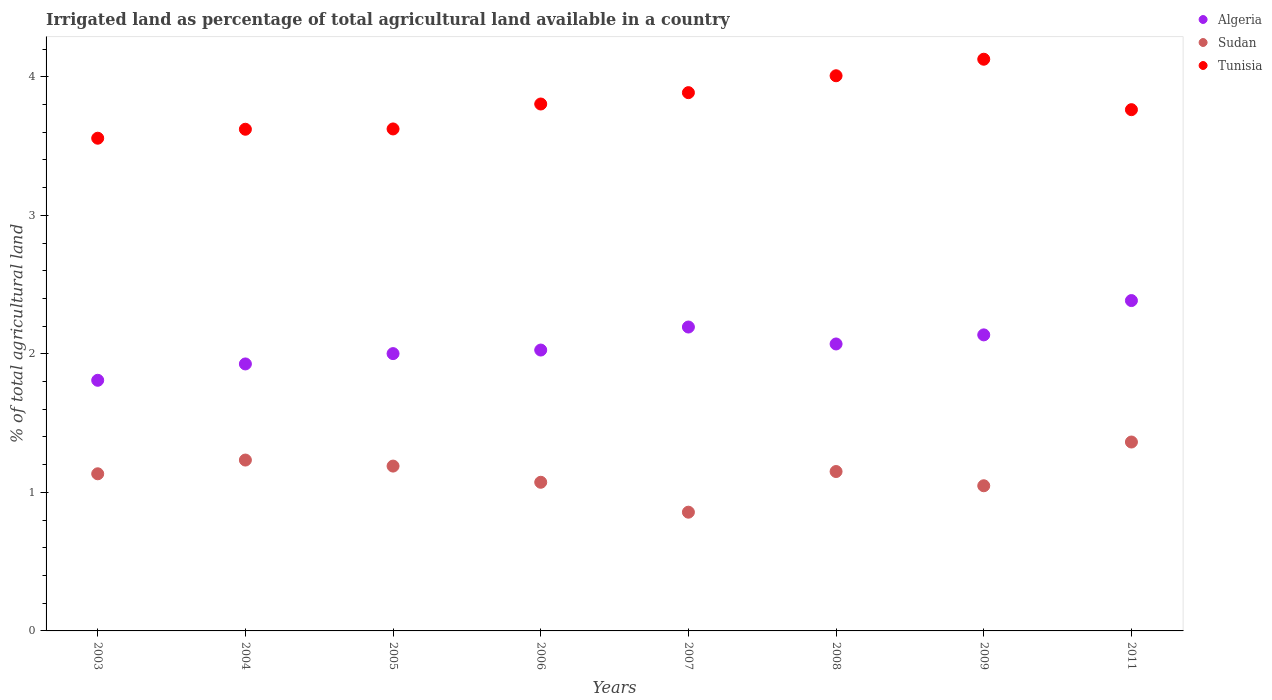How many different coloured dotlines are there?
Keep it short and to the point. 3. Is the number of dotlines equal to the number of legend labels?
Make the answer very short. Yes. What is the percentage of irrigated land in Algeria in 2004?
Provide a short and direct response. 1.93. Across all years, what is the maximum percentage of irrigated land in Algeria?
Your answer should be compact. 2.38. Across all years, what is the minimum percentage of irrigated land in Sudan?
Offer a terse response. 0.86. What is the total percentage of irrigated land in Sudan in the graph?
Provide a succinct answer. 9.05. What is the difference between the percentage of irrigated land in Tunisia in 2004 and that in 2006?
Your answer should be very brief. -0.18. What is the difference between the percentage of irrigated land in Tunisia in 2003 and the percentage of irrigated land in Sudan in 2009?
Provide a short and direct response. 2.51. What is the average percentage of irrigated land in Algeria per year?
Your answer should be very brief. 2.07. In the year 2006, what is the difference between the percentage of irrigated land in Algeria and percentage of irrigated land in Sudan?
Your answer should be very brief. 0.95. What is the ratio of the percentage of irrigated land in Sudan in 2004 to that in 2011?
Ensure brevity in your answer.  0.9. Is the percentage of irrigated land in Tunisia in 2009 less than that in 2011?
Offer a very short reply. No. What is the difference between the highest and the second highest percentage of irrigated land in Tunisia?
Provide a succinct answer. 0.12. What is the difference between the highest and the lowest percentage of irrigated land in Algeria?
Provide a succinct answer. 0.58. In how many years, is the percentage of irrigated land in Algeria greater than the average percentage of irrigated land in Algeria taken over all years?
Give a very brief answer. 4. Is the sum of the percentage of irrigated land in Tunisia in 2004 and 2007 greater than the maximum percentage of irrigated land in Sudan across all years?
Your response must be concise. Yes. Is it the case that in every year, the sum of the percentage of irrigated land in Algeria and percentage of irrigated land in Tunisia  is greater than the percentage of irrigated land in Sudan?
Your answer should be very brief. Yes. Does the percentage of irrigated land in Algeria monotonically increase over the years?
Your response must be concise. No. How many dotlines are there?
Provide a short and direct response. 3. How many years are there in the graph?
Offer a terse response. 8. What is the difference between two consecutive major ticks on the Y-axis?
Make the answer very short. 1. Are the values on the major ticks of Y-axis written in scientific E-notation?
Provide a succinct answer. No. Does the graph contain any zero values?
Your answer should be compact. No. Where does the legend appear in the graph?
Ensure brevity in your answer.  Top right. How are the legend labels stacked?
Your answer should be very brief. Vertical. What is the title of the graph?
Offer a very short reply. Irrigated land as percentage of total agricultural land available in a country. What is the label or title of the X-axis?
Provide a succinct answer. Years. What is the label or title of the Y-axis?
Ensure brevity in your answer.  % of total agricultural land. What is the % of total agricultural land of Algeria in 2003?
Provide a short and direct response. 1.81. What is the % of total agricultural land in Sudan in 2003?
Ensure brevity in your answer.  1.13. What is the % of total agricultural land in Tunisia in 2003?
Your answer should be very brief. 3.56. What is the % of total agricultural land in Algeria in 2004?
Ensure brevity in your answer.  1.93. What is the % of total agricultural land of Sudan in 2004?
Offer a very short reply. 1.23. What is the % of total agricultural land of Tunisia in 2004?
Keep it short and to the point. 3.62. What is the % of total agricultural land in Algeria in 2005?
Offer a terse response. 2. What is the % of total agricultural land in Sudan in 2005?
Your response must be concise. 1.19. What is the % of total agricultural land of Tunisia in 2005?
Provide a succinct answer. 3.62. What is the % of total agricultural land of Algeria in 2006?
Your response must be concise. 2.03. What is the % of total agricultural land in Sudan in 2006?
Your answer should be compact. 1.07. What is the % of total agricultural land of Tunisia in 2006?
Your answer should be very brief. 3.8. What is the % of total agricultural land of Algeria in 2007?
Provide a succinct answer. 2.19. What is the % of total agricultural land of Sudan in 2007?
Keep it short and to the point. 0.86. What is the % of total agricultural land in Tunisia in 2007?
Ensure brevity in your answer.  3.89. What is the % of total agricultural land in Algeria in 2008?
Make the answer very short. 2.07. What is the % of total agricultural land in Sudan in 2008?
Offer a terse response. 1.15. What is the % of total agricultural land in Tunisia in 2008?
Give a very brief answer. 4.01. What is the % of total agricultural land of Algeria in 2009?
Ensure brevity in your answer.  2.14. What is the % of total agricultural land of Sudan in 2009?
Provide a short and direct response. 1.05. What is the % of total agricultural land of Tunisia in 2009?
Ensure brevity in your answer.  4.13. What is the % of total agricultural land in Algeria in 2011?
Your response must be concise. 2.38. What is the % of total agricultural land of Sudan in 2011?
Give a very brief answer. 1.36. What is the % of total agricultural land of Tunisia in 2011?
Ensure brevity in your answer.  3.76. Across all years, what is the maximum % of total agricultural land in Algeria?
Keep it short and to the point. 2.38. Across all years, what is the maximum % of total agricultural land of Sudan?
Your answer should be very brief. 1.36. Across all years, what is the maximum % of total agricultural land of Tunisia?
Give a very brief answer. 4.13. Across all years, what is the minimum % of total agricultural land of Algeria?
Provide a succinct answer. 1.81. Across all years, what is the minimum % of total agricultural land in Sudan?
Provide a succinct answer. 0.86. Across all years, what is the minimum % of total agricultural land in Tunisia?
Your response must be concise. 3.56. What is the total % of total agricultural land of Algeria in the graph?
Provide a succinct answer. 16.55. What is the total % of total agricultural land in Sudan in the graph?
Your response must be concise. 9.05. What is the total % of total agricultural land in Tunisia in the graph?
Your answer should be very brief. 30.39. What is the difference between the % of total agricultural land of Algeria in 2003 and that in 2004?
Offer a terse response. -0.12. What is the difference between the % of total agricultural land of Sudan in 2003 and that in 2004?
Your answer should be compact. -0.1. What is the difference between the % of total agricultural land of Tunisia in 2003 and that in 2004?
Ensure brevity in your answer.  -0.06. What is the difference between the % of total agricultural land in Algeria in 2003 and that in 2005?
Your answer should be very brief. -0.19. What is the difference between the % of total agricultural land in Sudan in 2003 and that in 2005?
Provide a short and direct response. -0.06. What is the difference between the % of total agricultural land in Tunisia in 2003 and that in 2005?
Offer a very short reply. -0.07. What is the difference between the % of total agricultural land of Algeria in 2003 and that in 2006?
Ensure brevity in your answer.  -0.22. What is the difference between the % of total agricultural land of Sudan in 2003 and that in 2006?
Provide a succinct answer. 0.06. What is the difference between the % of total agricultural land of Tunisia in 2003 and that in 2006?
Your answer should be compact. -0.25. What is the difference between the % of total agricultural land in Algeria in 2003 and that in 2007?
Give a very brief answer. -0.38. What is the difference between the % of total agricultural land in Sudan in 2003 and that in 2007?
Make the answer very short. 0.28. What is the difference between the % of total agricultural land in Tunisia in 2003 and that in 2007?
Ensure brevity in your answer.  -0.33. What is the difference between the % of total agricultural land of Algeria in 2003 and that in 2008?
Make the answer very short. -0.26. What is the difference between the % of total agricultural land in Sudan in 2003 and that in 2008?
Your answer should be very brief. -0.02. What is the difference between the % of total agricultural land in Tunisia in 2003 and that in 2008?
Keep it short and to the point. -0.45. What is the difference between the % of total agricultural land in Algeria in 2003 and that in 2009?
Keep it short and to the point. -0.33. What is the difference between the % of total agricultural land of Sudan in 2003 and that in 2009?
Ensure brevity in your answer.  0.09. What is the difference between the % of total agricultural land of Tunisia in 2003 and that in 2009?
Offer a terse response. -0.57. What is the difference between the % of total agricultural land in Algeria in 2003 and that in 2011?
Offer a terse response. -0.58. What is the difference between the % of total agricultural land in Sudan in 2003 and that in 2011?
Make the answer very short. -0.23. What is the difference between the % of total agricultural land of Tunisia in 2003 and that in 2011?
Ensure brevity in your answer.  -0.21. What is the difference between the % of total agricultural land of Algeria in 2004 and that in 2005?
Give a very brief answer. -0.07. What is the difference between the % of total agricultural land of Sudan in 2004 and that in 2005?
Give a very brief answer. 0.04. What is the difference between the % of total agricultural land of Tunisia in 2004 and that in 2005?
Keep it short and to the point. -0. What is the difference between the % of total agricultural land in Algeria in 2004 and that in 2006?
Keep it short and to the point. -0.1. What is the difference between the % of total agricultural land in Sudan in 2004 and that in 2006?
Provide a succinct answer. 0.16. What is the difference between the % of total agricultural land in Tunisia in 2004 and that in 2006?
Ensure brevity in your answer.  -0.18. What is the difference between the % of total agricultural land of Algeria in 2004 and that in 2007?
Make the answer very short. -0.27. What is the difference between the % of total agricultural land of Sudan in 2004 and that in 2007?
Make the answer very short. 0.38. What is the difference between the % of total agricultural land in Tunisia in 2004 and that in 2007?
Make the answer very short. -0.26. What is the difference between the % of total agricultural land of Algeria in 2004 and that in 2008?
Make the answer very short. -0.14. What is the difference between the % of total agricultural land in Sudan in 2004 and that in 2008?
Make the answer very short. 0.08. What is the difference between the % of total agricultural land in Tunisia in 2004 and that in 2008?
Provide a succinct answer. -0.39. What is the difference between the % of total agricultural land of Algeria in 2004 and that in 2009?
Provide a short and direct response. -0.21. What is the difference between the % of total agricultural land of Sudan in 2004 and that in 2009?
Provide a succinct answer. 0.19. What is the difference between the % of total agricultural land in Tunisia in 2004 and that in 2009?
Your answer should be compact. -0.51. What is the difference between the % of total agricultural land of Algeria in 2004 and that in 2011?
Your response must be concise. -0.46. What is the difference between the % of total agricultural land of Sudan in 2004 and that in 2011?
Make the answer very short. -0.13. What is the difference between the % of total agricultural land in Tunisia in 2004 and that in 2011?
Your answer should be compact. -0.14. What is the difference between the % of total agricultural land of Algeria in 2005 and that in 2006?
Your response must be concise. -0.03. What is the difference between the % of total agricultural land in Sudan in 2005 and that in 2006?
Provide a short and direct response. 0.12. What is the difference between the % of total agricultural land of Tunisia in 2005 and that in 2006?
Offer a terse response. -0.18. What is the difference between the % of total agricultural land of Algeria in 2005 and that in 2007?
Provide a succinct answer. -0.19. What is the difference between the % of total agricultural land of Sudan in 2005 and that in 2007?
Provide a short and direct response. 0.33. What is the difference between the % of total agricultural land of Tunisia in 2005 and that in 2007?
Give a very brief answer. -0.26. What is the difference between the % of total agricultural land in Algeria in 2005 and that in 2008?
Keep it short and to the point. -0.07. What is the difference between the % of total agricultural land of Sudan in 2005 and that in 2008?
Provide a succinct answer. 0.04. What is the difference between the % of total agricultural land in Tunisia in 2005 and that in 2008?
Offer a very short reply. -0.38. What is the difference between the % of total agricultural land of Algeria in 2005 and that in 2009?
Offer a very short reply. -0.14. What is the difference between the % of total agricultural land in Sudan in 2005 and that in 2009?
Offer a very short reply. 0.14. What is the difference between the % of total agricultural land of Tunisia in 2005 and that in 2009?
Make the answer very short. -0.5. What is the difference between the % of total agricultural land in Algeria in 2005 and that in 2011?
Offer a terse response. -0.38. What is the difference between the % of total agricultural land in Sudan in 2005 and that in 2011?
Offer a very short reply. -0.17. What is the difference between the % of total agricultural land of Tunisia in 2005 and that in 2011?
Offer a terse response. -0.14. What is the difference between the % of total agricultural land in Algeria in 2006 and that in 2007?
Make the answer very short. -0.17. What is the difference between the % of total agricultural land in Sudan in 2006 and that in 2007?
Offer a terse response. 0.22. What is the difference between the % of total agricultural land in Tunisia in 2006 and that in 2007?
Provide a succinct answer. -0.08. What is the difference between the % of total agricultural land in Algeria in 2006 and that in 2008?
Provide a succinct answer. -0.04. What is the difference between the % of total agricultural land of Sudan in 2006 and that in 2008?
Offer a very short reply. -0.08. What is the difference between the % of total agricultural land in Tunisia in 2006 and that in 2008?
Provide a short and direct response. -0.2. What is the difference between the % of total agricultural land of Algeria in 2006 and that in 2009?
Provide a succinct answer. -0.11. What is the difference between the % of total agricultural land in Sudan in 2006 and that in 2009?
Keep it short and to the point. 0.03. What is the difference between the % of total agricultural land of Tunisia in 2006 and that in 2009?
Ensure brevity in your answer.  -0.32. What is the difference between the % of total agricultural land in Algeria in 2006 and that in 2011?
Provide a succinct answer. -0.36. What is the difference between the % of total agricultural land of Sudan in 2006 and that in 2011?
Make the answer very short. -0.29. What is the difference between the % of total agricultural land of Tunisia in 2006 and that in 2011?
Keep it short and to the point. 0.04. What is the difference between the % of total agricultural land of Algeria in 2007 and that in 2008?
Your answer should be compact. 0.12. What is the difference between the % of total agricultural land of Sudan in 2007 and that in 2008?
Your answer should be very brief. -0.29. What is the difference between the % of total agricultural land of Tunisia in 2007 and that in 2008?
Make the answer very short. -0.12. What is the difference between the % of total agricultural land of Algeria in 2007 and that in 2009?
Your answer should be very brief. 0.06. What is the difference between the % of total agricultural land of Sudan in 2007 and that in 2009?
Provide a short and direct response. -0.19. What is the difference between the % of total agricultural land in Tunisia in 2007 and that in 2009?
Offer a terse response. -0.24. What is the difference between the % of total agricultural land of Algeria in 2007 and that in 2011?
Offer a very short reply. -0.19. What is the difference between the % of total agricultural land in Sudan in 2007 and that in 2011?
Give a very brief answer. -0.51. What is the difference between the % of total agricultural land in Tunisia in 2007 and that in 2011?
Your answer should be compact. 0.12. What is the difference between the % of total agricultural land of Algeria in 2008 and that in 2009?
Offer a very short reply. -0.07. What is the difference between the % of total agricultural land in Sudan in 2008 and that in 2009?
Your answer should be very brief. 0.1. What is the difference between the % of total agricultural land of Tunisia in 2008 and that in 2009?
Your answer should be compact. -0.12. What is the difference between the % of total agricultural land in Algeria in 2008 and that in 2011?
Your answer should be very brief. -0.31. What is the difference between the % of total agricultural land of Sudan in 2008 and that in 2011?
Provide a succinct answer. -0.21. What is the difference between the % of total agricultural land in Tunisia in 2008 and that in 2011?
Your answer should be very brief. 0.24. What is the difference between the % of total agricultural land of Algeria in 2009 and that in 2011?
Your answer should be compact. -0.25. What is the difference between the % of total agricultural land in Sudan in 2009 and that in 2011?
Keep it short and to the point. -0.32. What is the difference between the % of total agricultural land in Tunisia in 2009 and that in 2011?
Provide a short and direct response. 0.36. What is the difference between the % of total agricultural land in Algeria in 2003 and the % of total agricultural land in Sudan in 2004?
Ensure brevity in your answer.  0.58. What is the difference between the % of total agricultural land in Algeria in 2003 and the % of total agricultural land in Tunisia in 2004?
Give a very brief answer. -1.81. What is the difference between the % of total agricultural land of Sudan in 2003 and the % of total agricultural land of Tunisia in 2004?
Provide a succinct answer. -2.49. What is the difference between the % of total agricultural land of Algeria in 2003 and the % of total agricultural land of Sudan in 2005?
Your response must be concise. 0.62. What is the difference between the % of total agricultural land of Algeria in 2003 and the % of total agricultural land of Tunisia in 2005?
Your answer should be very brief. -1.81. What is the difference between the % of total agricultural land in Sudan in 2003 and the % of total agricultural land in Tunisia in 2005?
Offer a terse response. -2.49. What is the difference between the % of total agricultural land of Algeria in 2003 and the % of total agricultural land of Sudan in 2006?
Your answer should be compact. 0.74. What is the difference between the % of total agricultural land in Algeria in 2003 and the % of total agricultural land in Tunisia in 2006?
Your response must be concise. -1.99. What is the difference between the % of total agricultural land of Sudan in 2003 and the % of total agricultural land of Tunisia in 2006?
Offer a terse response. -2.67. What is the difference between the % of total agricultural land of Algeria in 2003 and the % of total agricultural land of Sudan in 2007?
Provide a short and direct response. 0.95. What is the difference between the % of total agricultural land in Algeria in 2003 and the % of total agricultural land in Tunisia in 2007?
Make the answer very short. -2.08. What is the difference between the % of total agricultural land of Sudan in 2003 and the % of total agricultural land of Tunisia in 2007?
Offer a very short reply. -2.75. What is the difference between the % of total agricultural land in Algeria in 2003 and the % of total agricultural land in Sudan in 2008?
Make the answer very short. 0.66. What is the difference between the % of total agricultural land in Algeria in 2003 and the % of total agricultural land in Tunisia in 2008?
Offer a very short reply. -2.2. What is the difference between the % of total agricultural land of Sudan in 2003 and the % of total agricultural land of Tunisia in 2008?
Your response must be concise. -2.87. What is the difference between the % of total agricultural land in Algeria in 2003 and the % of total agricultural land in Sudan in 2009?
Offer a very short reply. 0.76. What is the difference between the % of total agricultural land of Algeria in 2003 and the % of total agricultural land of Tunisia in 2009?
Make the answer very short. -2.32. What is the difference between the % of total agricultural land of Sudan in 2003 and the % of total agricultural land of Tunisia in 2009?
Ensure brevity in your answer.  -2.99. What is the difference between the % of total agricultural land in Algeria in 2003 and the % of total agricultural land in Sudan in 2011?
Keep it short and to the point. 0.45. What is the difference between the % of total agricultural land in Algeria in 2003 and the % of total agricultural land in Tunisia in 2011?
Your answer should be very brief. -1.95. What is the difference between the % of total agricultural land in Sudan in 2003 and the % of total agricultural land in Tunisia in 2011?
Make the answer very short. -2.63. What is the difference between the % of total agricultural land in Algeria in 2004 and the % of total agricultural land in Sudan in 2005?
Offer a terse response. 0.74. What is the difference between the % of total agricultural land of Algeria in 2004 and the % of total agricultural land of Tunisia in 2005?
Keep it short and to the point. -1.7. What is the difference between the % of total agricultural land of Sudan in 2004 and the % of total agricultural land of Tunisia in 2005?
Provide a succinct answer. -2.39. What is the difference between the % of total agricultural land in Algeria in 2004 and the % of total agricultural land in Sudan in 2006?
Keep it short and to the point. 0.85. What is the difference between the % of total agricultural land in Algeria in 2004 and the % of total agricultural land in Tunisia in 2006?
Your answer should be very brief. -1.88. What is the difference between the % of total agricultural land of Sudan in 2004 and the % of total agricultural land of Tunisia in 2006?
Give a very brief answer. -2.57. What is the difference between the % of total agricultural land of Algeria in 2004 and the % of total agricultural land of Sudan in 2007?
Offer a very short reply. 1.07. What is the difference between the % of total agricultural land in Algeria in 2004 and the % of total agricultural land in Tunisia in 2007?
Ensure brevity in your answer.  -1.96. What is the difference between the % of total agricultural land of Sudan in 2004 and the % of total agricultural land of Tunisia in 2007?
Your answer should be compact. -2.65. What is the difference between the % of total agricultural land in Algeria in 2004 and the % of total agricultural land in Sudan in 2008?
Ensure brevity in your answer.  0.78. What is the difference between the % of total agricultural land of Algeria in 2004 and the % of total agricultural land of Tunisia in 2008?
Your response must be concise. -2.08. What is the difference between the % of total agricultural land of Sudan in 2004 and the % of total agricultural land of Tunisia in 2008?
Make the answer very short. -2.77. What is the difference between the % of total agricultural land of Algeria in 2004 and the % of total agricultural land of Sudan in 2009?
Give a very brief answer. 0.88. What is the difference between the % of total agricultural land in Algeria in 2004 and the % of total agricultural land in Tunisia in 2009?
Your response must be concise. -2.2. What is the difference between the % of total agricultural land of Sudan in 2004 and the % of total agricultural land of Tunisia in 2009?
Keep it short and to the point. -2.89. What is the difference between the % of total agricultural land in Algeria in 2004 and the % of total agricultural land in Sudan in 2011?
Give a very brief answer. 0.56. What is the difference between the % of total agricultural land in Algeria in 2004 and the % of total agricultural land in Tunisia in 2011?
Your answer should be very brief. -1.84. What is the difference between the % of total agricultural land of Sudan in 2004 and the % of total agricultural land of Tunisia in 2011?
Give a very brief answer. -2.53. What is the difference between the % of total agricultural land of Algeria in 2005 and the % of total agricultural land of Sudan in 2006?
Your response must be concise. 0.93. What is the difference between the % of total agricultural land of Algeria in 2005 and the % of total agricultural land of Tunisia in 2006?
Keep it short and to the point. -1.8. What is the difference between the % of total agricultural land of Sudan in 2005 and the % of total agricultural land of Tunisia in 2006?
Keep it short and to the point. -2.61. What is the difference between the % of total agricultural land of Algeria in 2005 and the % of total agricultural land of Sudan in 2007?
Keep it short and to the point. 1.14. What is the difference between the % of total agricultural land of Algeria in 2005 and the % of total agricultural land of Tunisia in 2007?
Provide a succinct answer. -1.88. What is the difference between the % of total agricultural land in Sudan in 2005 and the % of total agricultural land in Tunisia in 2007?
Provide a short and direct response. -2.7. What is the difference between the % of total agricultural land in Algeria in 2005 and the % of total agricultural land in Sudan in 2008?
Keep it short and to the point. 0.85. What is the difference between the % of total agricultural land in Algeria in 2005 and the % of total agricultural land in Tunisia in 2008?
Provide a succinct answer. -2.01. What is the difference between the % of total agricultural land in Sudan in 2005 and the % of total agricultural land in Tunisia in 2008?
Give a very brief answer. -2.82. What is the difference between the % of total agricultural land of Algeria in 2005 and the % of total agricultural land of Sudan in 2009?
Keep it short and to the point. 0.95. What is the difference between the % of total agricultural land of Algeria in 2005 and the % of total agricultural land of Tunisia in 2009?
Ensure brevity in your answer.  -2.13. What is the difference between the % of total agricultural land of Sudan in 2005 and the % of total agricultural land of Tunisia in 2009?
Your answer should be compact. -2.94. What is the difference between the % of total agricultural land of Algeria in 2005 and the % of total agricultural land of Sudan in 2011?
Your answer should be very brief. 0.64. What is the difference between the % of total agricultural land in Algeria in 2005 and the % of total agricultural land in Tunisia in 2011?
Ensure brevity in your answer.  -1.76. What is the difference between the % of total agricultural land of Sudan in 2005 and the % of total agricultural land of Tunisia in 2011?
Your response must be concise. -2.57. What is the difference between the % of total agricultural land in Algeria in 2006 and the % of total agricultural land in Sudan in 2007?
Offer a terse response. 1.17. What is the difference between the % of total agricultural land of Algeria in 2006 and the % of total agricultural land of Tunisia in 2007?
Provide a short and direct response. -1.86. What is the difference between the % of total agricultural land of Sudan in 2006 and the % of total agricultural land of Tunisia in 2007?
Give a very brief answer. -2.81. What is the difference between the % of total agricultural land in Algeria in 2006 and the % of total agricultural land in Sudan in 2008?
Ensure brevity in your answer.  0.88. What is the difference between the % of total agricultural land in Algeria in 2006 and the % of total agricultural land in Tunisia in 2008?
Your answer should be very brief. -1.98. What is the difference between the % of total agricultural land of Sudan in 2006 and the % of total agricultural land of Tunisia in 2008?
Your answer should be compact. -2.93. What is the difference between the % of total agricultural land of Algeria in 2006 and the % of total agricultural land of Sudan in 2009?
Make the answer very short. 0.98. What is the difference between the % of total agricultural land of Algeria in 2006 and the % of total agricultural land of Tunisia in 2009?
Offer a terse response. -2.1. What is the difference between the % of total agricultural land in Sudan in 2006 and the % of total agricultural land in Tunisia in 2009?
Give a very brief answer. -3.05. What is the difference between the % of total agricultural land of Algeria in 2006 and the % of total agricultural land of Sudan in 2011?
Offer a very short reply. 0.66. What is the difference between the % of total agricultural land in Algeria in 2006 and the % of total agricultural land in Tunisia in 2011?
Provide a succinct answer. -1.74. What is the difference between the % of total agricultural land of Sudan in 2006 and the % of total agricultural land of Tunisia in 2011?
Make the answer very short. -2.69. What is the difference between the % of total agricultural land in Algeria in 2007 and the % of total agricultural land in Sudan in 2008?
Give a very brief answer. 1.04. What is the difference between the % of total agricultural land in Algeria in 2007 and the % of total agricultural land in Tunisia in 2008?
Keep it short and to the point. -1.81. What is the difference between the % of total agricultural land in Sudan in 2007 and the % of total agricultural land in Tunisia in 2008?
Your response must be concise. -3.15. What is the difference between the % of total agricultural land in Algeria in 2007 and the % of total agricultural land in Sudan in 2009?
Ensure brevity in your answer.  1.15. What is the difference between the % of total agricultural land of Algeria in 2007 and the % of total agricultural land of Tunisia in 2009?
Your answer should be compact. -1.93. What is the difference between the % of total agricultural land of Sudan in 2007 and the % of total agricultural land of Tunisia in 2009?
Your answer should be compact. -3.27. What is the difference between the % of total agricultural land in Algeria in 2007 and the % of total agricultural land in Sudan in 2011?
Offer a terse response. 0.83. What is the difference between the % of total agricultural land of Algeria in 2007 and the % of total agricultural land of Tunisia in 2011?
Provide a succinct answer. -1.57. What is the difference between the % of total agricultural land of Sudan in 2007 and the % of total agricultural land of Tunisia in 2011?
Give a very brief answer. -2.91. What is the difference between the % of total agricultural land in Algeria in 2008 and the % of total agricultural land in Sudan in 2009?
Provide a succinct answer. 1.02. What is the difference between the % of total agricultural land in Algeria in 2008 and the % of total agricultural land in Tunisia in 2009?
Your answer should be compact. -2.06. What is the difference between the % of total agricultural land in Sudan in 2008 and the % of total agricultural land in Tunisia in 2009?
Your response must be concise. -2.98. What is the difference between the % of total agricultural land of Algeria in 2008 and the % of total agricultural land of Sudan in 2011?
Give a very brief answer. 0.71. What is the difference between the % of total agricultural land of Algeria in 2008 and the % of total agricultural land of Tunisia in 2011?
Give a very brief answer. -1.69. What is the difference between the % of total agricultural land in Sudan in 2008 and the % of total agricultural land in Tunisia in 2011?
Your response must be concise. -2.61. What is the difference between the % of total agricultural land in Algeria in 2009 and the % of total agricultural land in Sudan in 2011?
Provide a short and direct response. 0.77. What is the difference between the % of total agricultural land of Algeria in 2009 and the % of total agricultural land of Tunisia in 2011?
Your answer should be compact. -1.63. What is the difference between the % of total agricultural land in Sudan in 2009 and the % of total agricultural land in Tunisia in 2011?
Offer a terse response. -2.71. What is the average % of total agricultural land in Algeria per year?
Ensure brevity in your answer.  2.07. What is the average % of total agricultural land of Sudan per year?
Give a very brief answer. 1.13. What is the average % of total agricultural land in Tunisia per year?
Your response must be concise. 3.8. In the year 2003, what is the difference between the % of total agricultural land of Algeria and % of total agricultural land of Sudan?
Your answer should be very brief. 0.67. In the year 2003, what is the difference between the % of total agricultural land in Algeria and % of total agricultural land in Tunisia?
Make the answer very short. -1.75. In the year 2003, what is the difference between the % of total agricultural land in Sudan and % of total agricultural land in Tunisia?
Provide a succinct answer. -2.42. In the year 2004, what is the difference between the % of total agricultural land of Algeria and % of total agricultural land of Sudan?
Give a very brief answer. 0.69. In the year 2004, what is the difference between the % of total agricultural land of Algeria and % of total agricultural land of Tunisia?
Ensure brevity in your answer.  -1.69. In the year 2004, what is the difference between the % of total agricultural land of Sudan and % of total agricultural land of Tunisia?
Provide a succinct answer. -2.39. In the year 2005, what is the difference between the % of total agricultural land of Algeria and % of total agricultural land of Sudan?
Keep it short and to the point. 0.81. In the year 2005, what is the difference between the % of total agricultural land in Algeria and % of total agricultural land in Tunisia?
Your response must be concise. -1.62. In the year 2005, what is the difference between the % of total agricultural land in Sudan and % of total agricultural land in Tunisia?
Offer a terse response. -2.43. In the year 2006, what is the difference between the % of total agricultural land of Algeria and % of total agricultural land of Sudan?
Provide a short and direct response. 0.95. In the year 2006, what is the difference between the % of total agricultural land in Algeria and % of total agricultural land in Tunisia?
Give a very brief answer. -1.78. In the year 2006, what is the difference between the % of total agricultural land in Sudan and % of total agricultural land in Tunisia?
Provide a short and direct response. -2.73. In the year 2007, what is the difference between the % of total agricultural land in Algeria and % of total agricultural land in Sudan?
Provide a short and direct response. 1.34. In the year 2007, what is the difference between the % of total agricultural land of Algeria and % of total agricultural land of Tunisia?
Your answer should be very brief. -1.69. In the year 2007, what is the difference between the % of total agricultural land in Sudan and % of total agricultural land in Tunisia?
Offer a terse response. -3.03. In the year 2008, what is the difference between the % of total agricultural land in Algeria and % of total agricultural land in Sudan?
Keep it short and to the point. 0.92. In the year 2008, what is the difference between the % of total agricultural land in Algeria and % of total agricultural land in Tunisia?
Offer a very short reply. -1.94. In the year 2008, what is the difference between the % of total agricultural land in Sudan and % of total agricultural land in Tunisia?
Your answer should be very brief. -2.86. In the year 2009, what is the difference between the % of total agricultural land of Algeria and % of total agricultural land of Sudan?
Offer a very short reply. 1.09. In the year 2009, what is the difference between the % of total agricultural land of Algeria and % of total agricultural land of Tunisia?
Ensure brevity in your answer.  -1.99. In the year 2009, what is the difference between the % of total agricultural land of Sudan and % of total agricultural land of Tunisia?
Ensure brevity in your answer.  -3.08. In the year 2011, what is the difference between the % of total agricultural land of Algeria and % of total agricultural land of Sudan?
Provide a succinct answer. 1.02. In the year 2011, what is the difference between the % of total agricultural land of Algeria and % of total agricultural land of Tunisia?
Offer a very short reply. -1.38. In the year 2011, what is the difference between the % of total agricultural land of Sudan and % of total agricultural land of Tunisia?
Provide a short and direct response. -2.4. What is the ratio of the % of total agricultural land of Algeria in 2003 to that in 2004?
Keep it short and to the point. 0.94. What is the ratio of the % of total agricultural land in Sudan in 2003 to that in 2004?
Make the answer very short. 0.92. What is the ratio of the % of total agricultural land of Tunisia in 2003 to that in 2004?
Keep it short and to the point. 0.98. What is the ratio of the % of total agricultural land in Algeria in 2003 to that in 2005?
Ensure brevity in your answer.  0.9. What is the ratio of the % of total agricultural land in Sudan in 2003 to that in 2005?
Your answer should be compact. 0.95. What is the ratio of the % of total agricultural land in Tunisia in 2003 to that in 2005?
Ensure brevity in your answer.  0.98. What is the ratio of the % of total agricultural land in Algeria in 2003 to that in 2006?
Ensure brevity in your answer.  0.89. What is the ratio of the % of total agricultural land of Sudan in 2003 to that in 2006?
Provide a short and direct response. 1.06. What is the ratio of the % of total agricultural land of Tunisia in 2003 to that in 2006?
Offer a very short reply. 0.94. What is the ratio of the % of total agricultural land of Algeria in 2003 to that in 2007?
Your answer should be very brief. 0.82. What is the ratio of the % of total agricultural land in Sudan in 2003 to that in 2007?
Your answer should be compact. 1.32. What is the ratio of the % of total agricultural land of Tunisia in 2003 to that in 2007?
Your answer should be compact. 0.92. What is the ratio of the % of total agricultural land of Algeria in 2003 to that in 2008?
Offer a very short reply. 0.87. What is the ratio of the % of total agricultural land of Sudan in 2003 to that in 2008?
Your answer should be very brief. 0.99. What is the ratio of the % of total agricultural land of Tunisia in 2003 to that in 2008?
Offer a very short reply. 0.89. What is the ratio of the % of total agricultural land in Algeria in 2003 to that in 2009?
Your answer should be compact. 0.85. What is the ratio of the % of total agricultural land of Sudan in 2003 to that in 2009?
Your answer should be very brief. 1.08. What is the ratio of the % of total agricultural land of Tunisia in 2003 to that in 2009?
Offer a terse response. 0.86. What is the ratio of the % of total agricultural land of Algeria in 2003 to that in 2011?
Your response must be concise. 0.76. What is the ratio of the % of total agricultural land of Sudan in 2003 to that in 2011?
Make the answer very short. 0.83. What is the ratio of the % of total agricultural land in Tunisia in 2003 to that in 2011?
Give a very brief answer. 0.95. What is the ratio of the % of total agricultural land of Algeria in 2004 to that in 2005?
Give a very brief answer. 0.96. What is the ratio of the % of total agricultural land of Sudan in 2004 to that in 2005?
Offer a terse response. 1.04. What is the ratio of the % of total agricultural land of Tunisia in 2004 to that in 2005?
Give a very brief answer. 1. What is the ratio of the % of total agricultural land in Algeria in 2004 to that in 2006?
Offer a terse response. 0.95. What is the ratio of the % of total agricultural land of Sudan in 2004 to that in 2006?
Offer a terse response. 1.15. What is the ratio of the % of total agricultural land of Tunisia in 2004 to that in 2006?
Provide a short and direct response. 0.95. What is the ratio of the % of total agricultural land in Algeria in 2004 to that in 2007?
Keep it short and to the point. 0.88. What is the ratio of the % of total agricultural land of Sudan in 2004 to that in 2007?
Offer a very short reply. 1.44. What is the ratio of the % of total agricultural land of Tunisia in 2004 to that in 2007?
Your answer should be compact. 0.93. What is the ratio of the % of total agricultural land of Algeria in 2004 to that in 2008?
Offer a very short reply. 0.93. What is the ratio of the % of total agricultural land of Sudan in 2004 to that in 2008?
Your answer should be compact. 1.07. What is the ratio of the % of total agricultural land of Tunisia in 2004 to that in 2008?
Make the answer very short. 0.9. What is the ratio of the % of total agricultural land in Algeria in 2004 to that in 2009?
Give a very brief answer. 0.9. What is the ratio of the % of total agricultural land in Sudan in 2004 to that in 2009?
Provide a succinct answer. 1.18. What is the ratio of the % of total agricultural land of Tunisia in 2004 to that in 2009?
Keep it short and to the point. 0.88. What is the ratio of the % of total agricultural land of Algeria in 2004 to that in 2011?
Offer a terse response. 0.81. What is the ratio of the % of total agricultural land in Sudan in 2004 to that in 2011?
Ensure brevity in your answer.  0.9. What is the ratio of the % of total agricultural land in Tunisia in 2004 to that in 2011?
Offer a very short reply. 0.96. What is the ratio of the % of total agricultural land of Algeria in 2005 to that in 2006?
Ensure brevity in your answer.  0.99. What is the ratio of the % of total agricultural land in Sudan in 2005 to that in 2006?
Provide a succinct answer. 1.11. What is the ratio of the % of total agricultural land in Tunisia in 2005 to that in 2006?
Your answer should be very brief. 0.95. What is the ratio of the % of total agricultural land in Algeria in 2005 to that in 2007?
Your response must be concise. 0.91. What is the ratio of the % of total agricultural land in Sudan in 2005 to that in 2007?
Your response must be concise. 1.39. What is the ratio of the % of total agricultural land of Tunisia in 2005 to that in 2007?
Ensure brevity in your answer.  0.93. What is the ratio of the % of total agricultural land in Algeria in 2005 to that in 2008?
Provide a succinct answer. 0.97. What is the ratio of the % of total agricultural land in Sudan in 2005 to that in 2008?
Offer a terse response. 1.03. What is the ratio of the % of total agricultural land of Tunisia in 2005 to that in 2008?
Keep it short and to the point. 0.9. What is the ratio of the % of total agricultural land in Algeria in 2005 to that in 2009?
Provide a succinct answer. 0.94. What is the ratio of the % of total agricultural land of Sudan in 2005 to that in 2009?
Your answer should be very brief. 1.14. What is the ratio of the % of total agricultural land in Tunisia in 2005 to that in 2009?
Make the answer very short. 0.88. What is the ratio of the % of total agricultural land of Algeria in 2005 to that in 2011?
Ensure brevity in your answer.  0.84. What is the ratio of the % of total agricultural land of Sudan in 2005 to that in 2011?
Keep it short and to the point. 0.87. What is the ratio of the % of total agricultural land of Tunisia in 2005 to that in 2011?
Ensure brevity in your answer.  0.96. What is the ratio of the % of total agricultural land in Algeria in 2006 to that in 2007?
Offer a very short reply. 0.92. What is the ratio of the % of total agricultural land of Sudan in 2006 to that in 2007?
Offer a terse response. 1.25. What is the ratio of the % of total agricultural land of Tunisia in 2006 to that in 2007?
Ensure brevity in your answer.  0.98. What is the ratio of the % of total agricultural land in Algeria in 2006 to that in 2008?
Your response must be concise. 0.98. What is the ratio of the % of total agricultural land in Sudan in 2006 to that in 2008?
Offer a terse response. 0.93. What is the ratio of the % of total agricultural land of Tunisia in 2006 to that in 2008?
Provide a short and direct response. 0.95. What is the ratio of the % of total agricultural land of Algeria in 2006 to that in 2009?
Provide a succinct answer. 0.95. What is the ratio of the % of total agricultural land of Sudan in 2006 to that in 2009?
Provide a short and direct response. 1.02. What is the ratio of the % of total agricultural land of Tunisia in 2006 to that in 2009?
Keep it short and to the point. 0.92. What is the ratio of the % of total agricultural land in Algeria in 2006 to that in 2011?
Your response must be concise. 0.85. What is the ratio of the % of total agricultural land in Sudan in 2006 to that in 2011?
Offer a terse response. 0.79. What is the ratio of the % of total agricultural land of Tunisia in 2006 to that in 2011?
Provide a short and direct response. 1.01. What is the ratio of the % of total agricultural land in Algeria in 2007 to that in 2008?
Your answer should be very brief. 1.06. What is the ratio of the % of total agricultural land in Sudan in 2007 to that in 2008?
Your answer should be very brief. 0.74. What is the ratio of the % of total agricultural land in Tunisia in 2007 to that in 2008?
Offer a terse response. 0.97. What is the ratio of the % of total agricultural land of Algeria in 2007 to that in 2009?
Your response must be concise. 1.03. What is the ratio of the % of total agricultural land in Sudan in 2007 to that in 2009?
Offer a very short reply. 0.82. What is the ratio of the % of total agricultural land of Tunisia in 2007 to that in 2009?
Offer a terse response. 0.94. What is the ratio of the % of total agricultural land in Algeria in 2007 to that in 2011?
Give a very brief answer. 0.92. What is the ratio of the % of total agricultural land of Sudan in 2007 to that in 2011?
Make the answer very short. 0.63. What is the ratio of the % of total agricultural land in Tunisia in 2007 to that in 2011?
Give a very brief answer. 1.03. What is the ratio of the % of total agricultural land in Algeria in 2008 to that in 2009?
Offer a terse response. 0.97. What is the ratio of the % of total agricultural land of Sudan in 2008 to that in 2009?
Your response must be concise. 1.1. What is the ratio of the % of total agricultural land of Tunisia in 2008 to that in 2009?
Make the answer very short. 0.97. What is the ratio of the % of total agricultural land of Algeria in 2008 to that in 2011?
Make the answer very short. 0.87. What is the ratio of the % of total agricultural land of Sudan in 2008 to that in 2011?
Your answer should be very brief. 0.84. What is the ratio of the % of total agricultural land in Tunisia in 2008 to that in 2011?
Keep it short and to the point. 1.07. What is the ratio of the % of total agricultural land in Algeria in 2009 to that in 2011?
Offer a terse response. 0.9. What is the ratio of the % of total agricultural land in Sudan in 2009 to that in 2011?
Offer a very short reply. 0.77. What is the ratio of the % of total agricultural land in Tunisia in 2009 to that in 2011?
Offer a very short reply. 1.1. What is the difference between the highest and the second highest % of total agricultural land of Algeria?
Your answer should be compact. 0.19. What is the difference between the highest and the second highest % of total agricultural land in Sudan?
Offer a very short reply. 0.13. What is the difference between the highest and the second highest % of total agricultural land of Tunisia?
Keep it short and to the point. 0.12. What is the difference between the highest and the lowest % of total agricultural land in Algeria?
Keep it short and to the point. 0.58. What is the difference between the highest and the lowest % of total agricultural land of Sudan?
Offer a very short reply. 0.51. What is the difference between the highest and the lowest % of total agricultural land in Tunisia?
Keep it short and to the point. 0.57. 